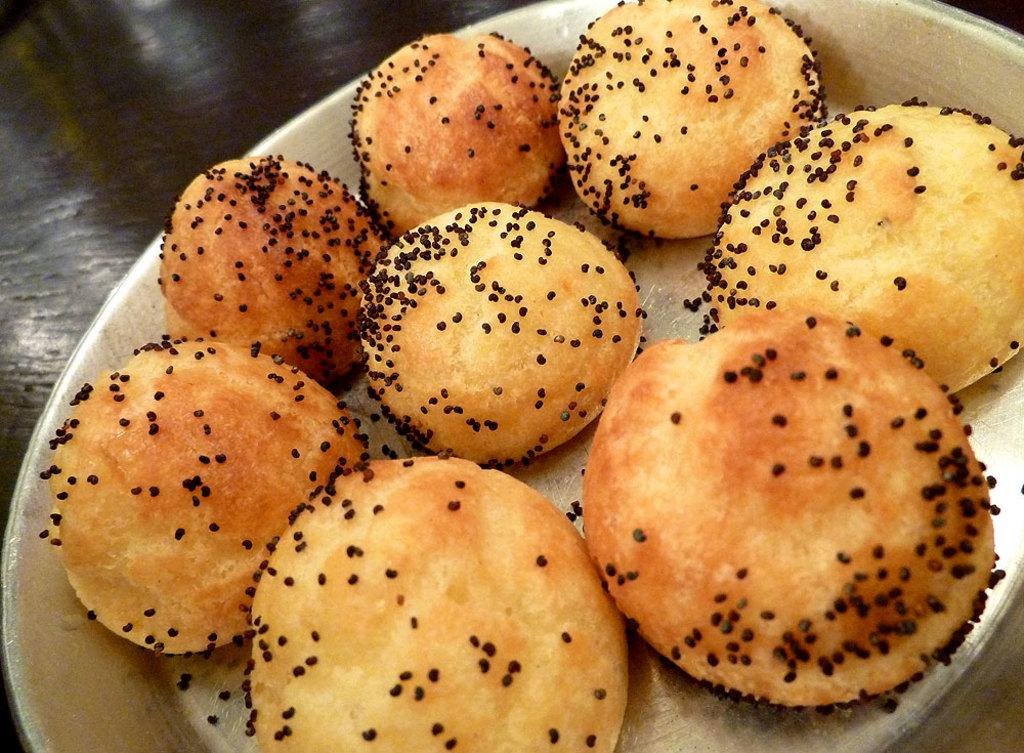What object is present on the table in the image? There is a plate in the image. What is on the plate? The plate has food on it. Where is the plate located? The plate is placed on a table. How many children are sitting on the plate in the image? There are no children present in the image, and the plate is not large enough to accommodate any. 